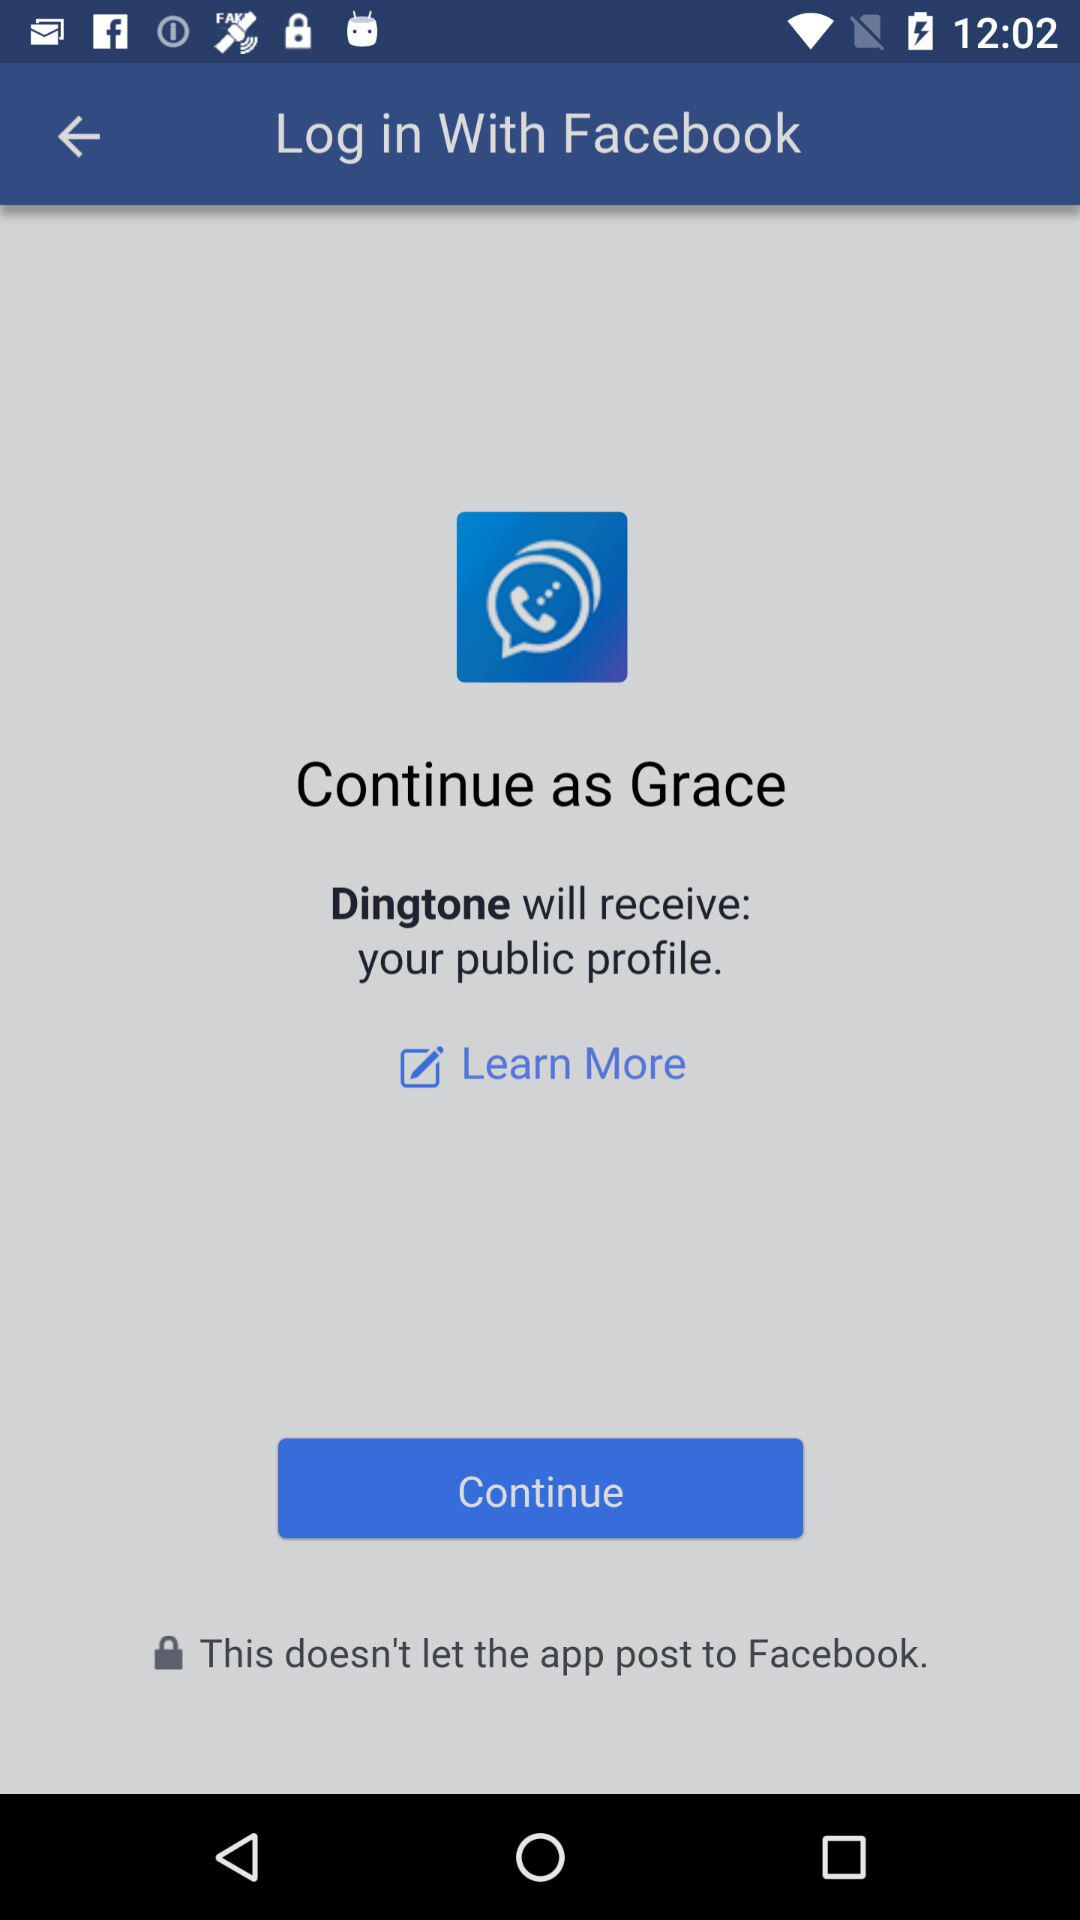What application is asking for permission? The application "Dingtone" is asking for permission. 